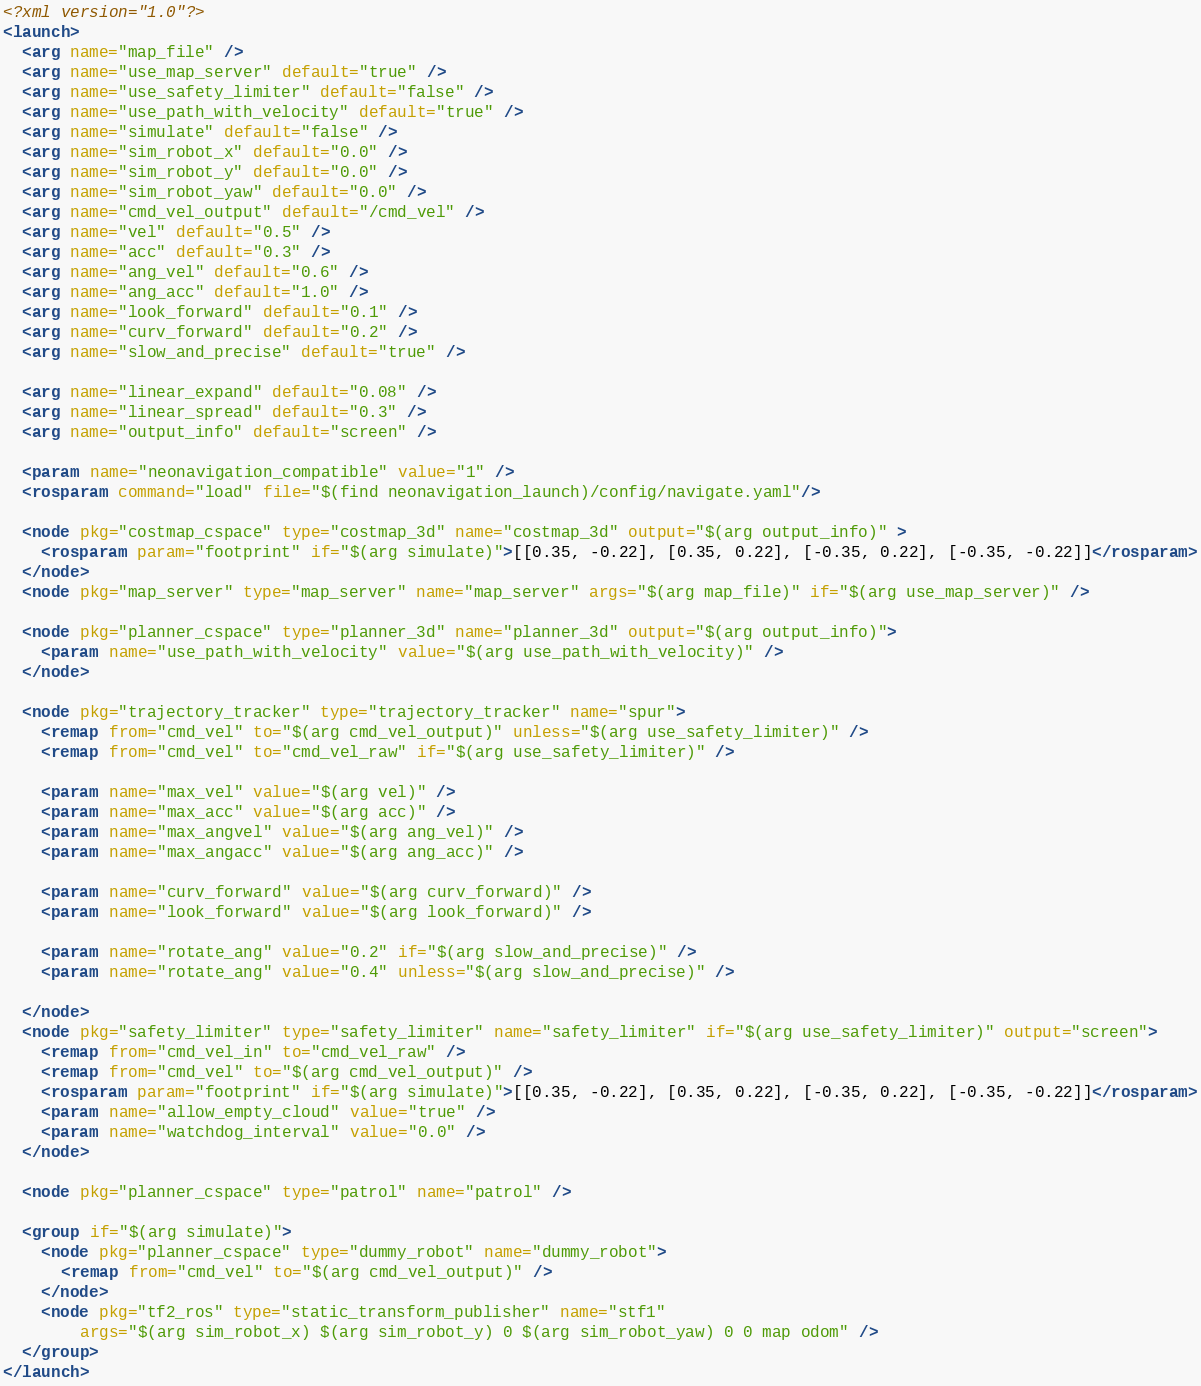<code> <loc_0><loc_0><loc_500><loc_500><_XML_><?xml version="1.0"?>
<launch>
  <arg name="map_file" />
  <arg name="use_map_server" default="true" />
  <arg name="use_safety_limiter" default="false" />
  <arg name="use_path_with_velocity" default="true" />
  <arg name="simulate" default="false" />
  <arg name="sim_robot_x" default="0.0" />
  <arg name="sim_robot_y" default="0.0" />
  <arg name="sim_robot_yaw" default="0.0" />
  <arg name="cmd_vel_output" default="/cmd_vel" />
  <arg name="vel" default="0.5" />
  <arg name="acc" default="0.3" />
  <arg name="ang_vel" default="0.6" />
  <arg name="ang_acc" default="1.0" />
  <arg name="look_forward" default="0.1" />
  <arg name="curv_forward" default="0.2" />
  <arg name="slow_and_precise" default="true" />

  <arg name="linear_expand" default="0.08" />
  <arg name="linear_spread" default="0.3" />
  <arg name="output_info" default="screen" />

  <param name="neonavigation_compatible" value="1" />
  <rosparam command="load" file="$(find neonavigation_launch)/config/navigate.yaml"/>

  <node pkg="costmap_cspace" type="costmap_3d" name="costmap_3d" output="$(arg output_info)" >
    <rosparam param="footprint" if="$(arg simulate)">[[0.35, -0.22], [0.35, 0.22], [-0.35, 0.22], [-0.35, -0.22]]</rosparam>
  </node>
  <node pkg="map_server" type="map_server" name="map_server" args="$(arg map_file)" if="$(arg use_map_server)" />

  <node pkg="planner_cspace" type="planner_3d" name="planner_3d" output="$(arg output_info)">
    <param name="use_path_with_velocity" value="$(arg use_path_with_velocity)" />
  </node>

  <node pkg="trajectory_tracker" type="trajectory_tracker" name="spur">
    <remap from="cmd_vel" to="$(arg cmd_vel_output)" unless="$(arg use_safety_limiter)" />
    <remap from="cmd_vel" to="cmd_vel_raw" if="$(arg use_safety_limiter)" />

    <param name="max_vel" value="$(arg vel)" />
    <param name="max_acc" value="$(arg acc)" />
    <param name="max_angvel" value="$(arg ang_vel)" />
    <param name="max_angacc" value="$(arg ang_acc)" />

    <param name="curv_forward" value="$(arg curv_forward)" />
    <param name="look_forward" value="$(arg look_forward)" />

    <param name="rotate_ang" value="0.2" if="$(arg slow_and_precise)" />
    <param name="rotate_ang" value="0.4" unless="$(arg slow_and_precise)" />

  </node>
  <node pkg="safety_limiter" type="safety_limiter" name="safety_limiter" if="$(arg use_safety_limiter)" output="screen">
    <remap from="cmd_vel_in" to="cmd_vel_raw" />
    <remap from="cmd_vel" to="$(arg cmd_vel_output)" />
    <rosparam param="footprint" if="$(arg simulate)">[[0.35, -0.22], [0.35, 0.22], [-0.35, 0.22], [-0.35, -0.22]]</rosparam>
    <param name="allow_empty_cloud" value="true" />
    <param name="watchdog_interval" value="0.0" />
  </node>

  <node pkg="planner_cspace" type="patrol" name="patrol" />

  <group if="$(arg simulate)">
    <node pkg="planner_cspace" type="dummy_robot" name="dummy_robot">
      <remap from="cmd_vel" to="$(arg cmd_vel_output)" />
    </node>
    <node pkg="tf2_ros" type="static_transform_publisher" name="stf1"
        args="$(arg sim_robot_x) $(arg sim_robot_y) 0 $(arg sim_robot_yaw) 0 0 map odom" />
  </group>
</launch>

</code> 